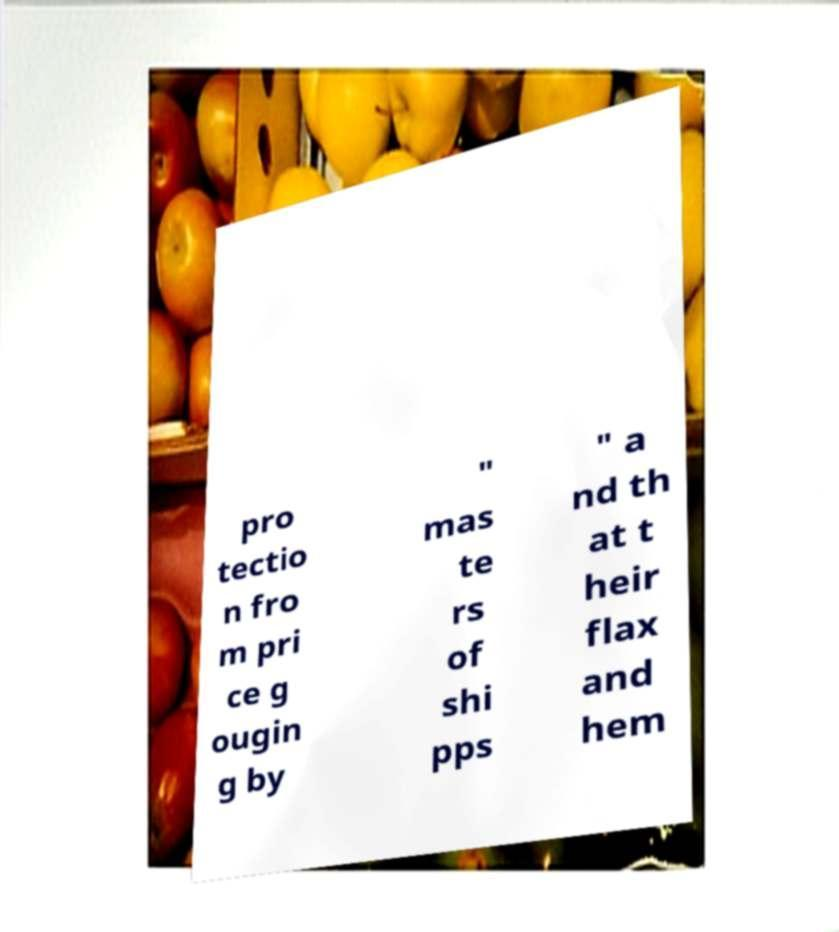What messages or text are displayed in this image? I need them in a readable, typed format. pro tectio n fro m pri ce g ougin g by " mas te rs of shi pps " a nd th at t heir flax and hem 